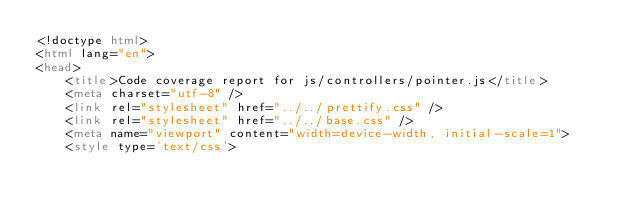Convert code to text. <code><loc_0><loc_0><loc_500><loc_500><_HTML_><!doctype html>
<html lang="en">
<head>
    <title>Code coverage report for js/controllers/pointer.js</title>
    <meta charset="utf-8" />
    <link rel="stylesheet" href="../../prettify.css" />
    <link rel="stylesheet" href="../../base.css" />
    <meta name="viewport" content="width=device-width, initial-scale=1">
    <style type='text/css'></code> 